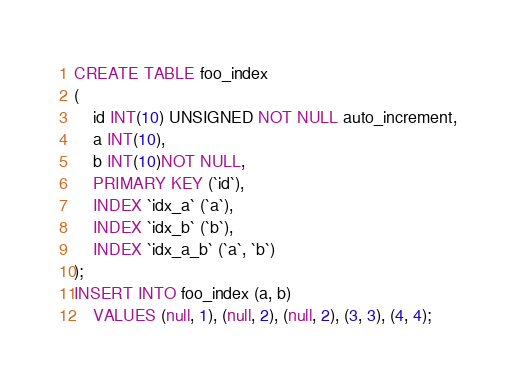<code> <loc_0><loc_0><loc_500><loc_500><_SQL_>CREATE TABLE foo_index
(
    id INT(10) UNSIGNED NOT NULL auto_increment,
    a INT(10),
    b INT(10)NOT NULL,
    PRIMARY KEY (`id`),
    INDEX `idx_a` (`a`),
    INDEX `idx_b` (`b`),
    INDEX `idx_a_b` (`a`, `b`)
);
INSERT INTO foo_index (a, b)
    VALUES (null, 1), (null, 2), (null, 2), (3, 3), (4, 4);
</code> 